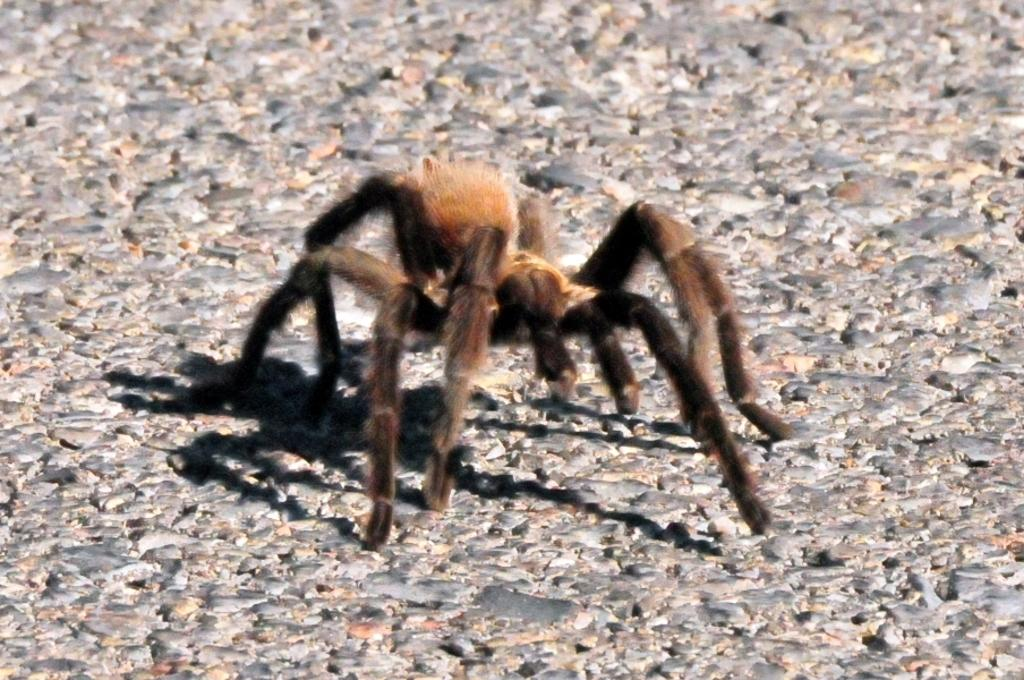What type of creature is present in the image? There is an insect in the image. Where is the insect located in the image? The insect is on the floor. What type of soup is being served in the image? There is no soup present in the image; it features an insect on the floor. How many kittens can be seen playing with the zephyr in the image? There are no kittens or zephyr present in the image. 